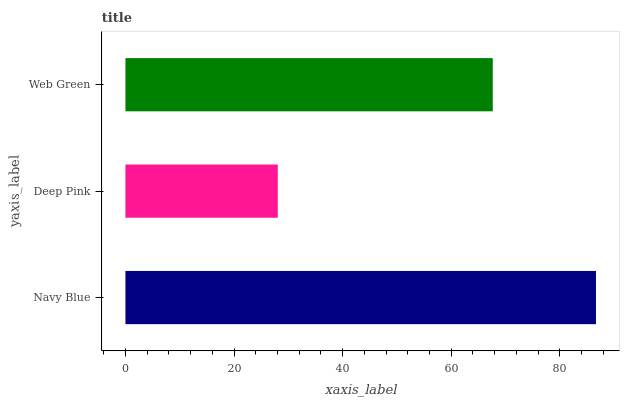Is Deep Pink the minimum?
Answer yes or no. Yes. Is Navy Blue the maximum?
Answer yes or no. Yes. Is Web Green the minimum?
Answer yes or no. No. Is Web Green the maximum?
Answer yes or no. No. Is Web Green greater than Deep Pink?
Answer yes or no. Yes. Is Deep Pink less than Web Green?
Answer yes or no. Yes. Is Deep Pink greater than Web Green?
Answer yes or no. No. Is Web Green less than Deep Pink?
Answer yes or no. No. Is Web Green the high median?
Answer yes or no. Yes. Is Web Green the low median?
Answer yes or no. Yes. Is Navy Blue the high median?
Answer yes or no. No. Is Deep Pink the low median?
Answer yes or no. No. 